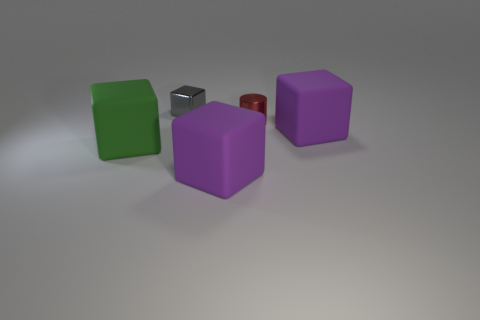Subtract all shiny blocks. How many blocks are left? 3 Subtract 2 cubes. How many cubes are left? 2 Subtract all gray cubes. How many cubes are left? 3 Subtract all red blocks. Subtract all red balls. How many blocks are left? 4 Add 1 green rubber blocks. How many objects exist? 6 Subtract all blocks. How many objects are left? 1 Add 2 metallic cubes. How many metallic cubes exist? 3 Subtract 0 purple spheres. How many objects are left? 5 Subtract all tiny blue metal spheres. Subtract all gray metallic cubes. How many objects are left? 4 Add 1 green matte cubes. How many green matte cubes are left? 2 